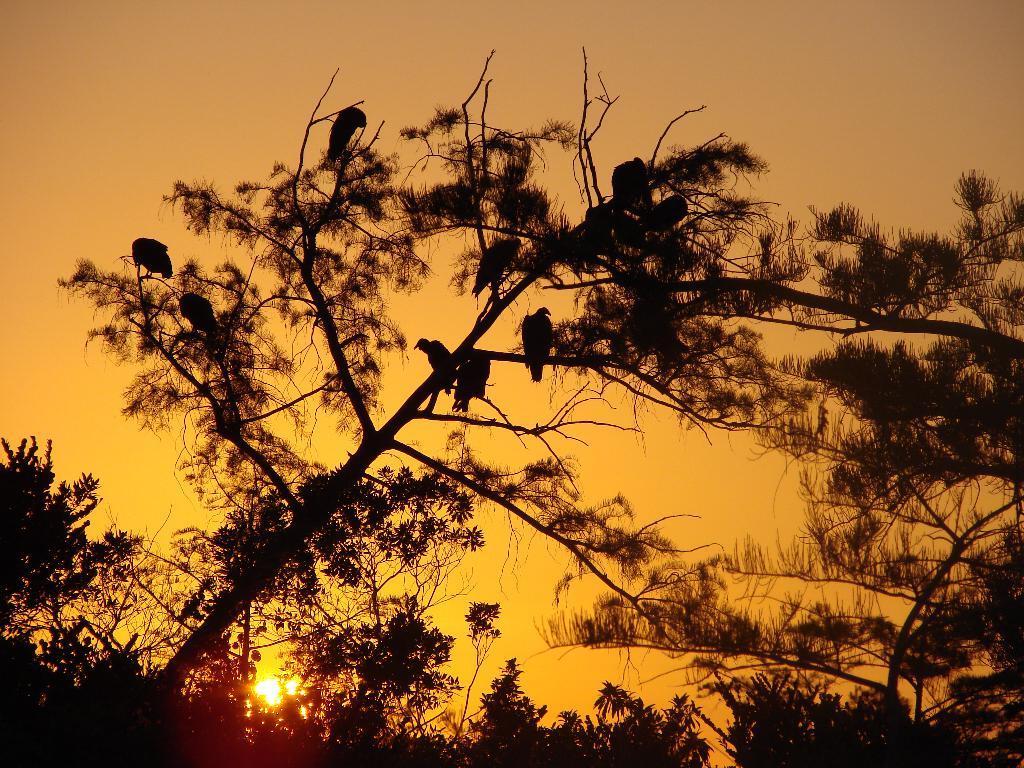Please provide a concise description of this image. In this image there are birds on the tree. Background there are trees. Behind there is sky, having the sun. 